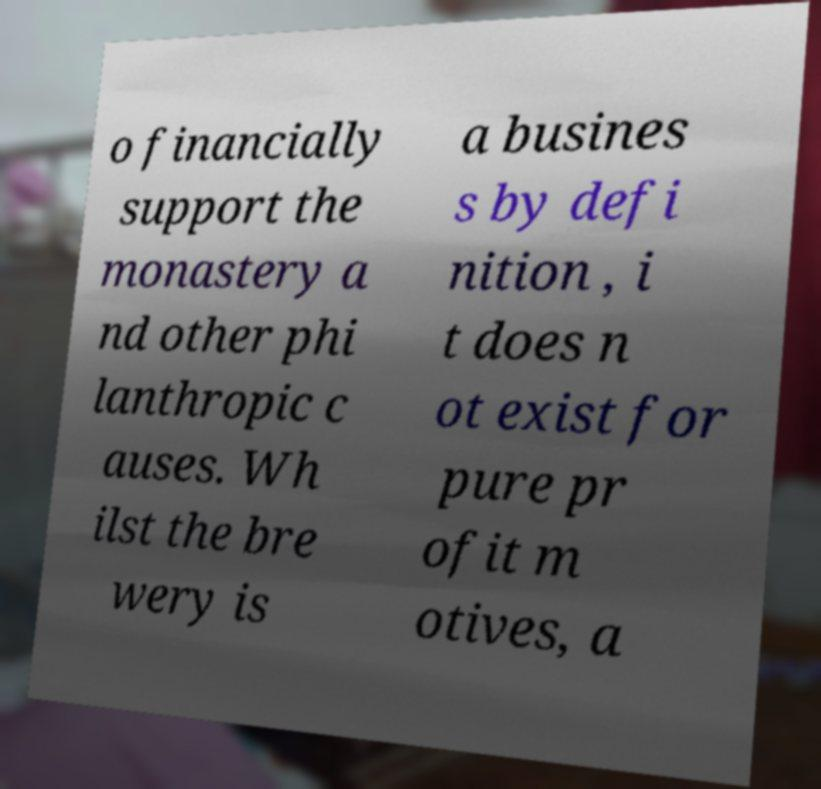Could you assist in decoding the text presented in this image and type it out clearly? o financially support the monastery a nd other phi lanthropic c auses. Wh ilst the bre wery is a busines s by defi nition , i t does n ot exist for pure pr ofit m otives, a 